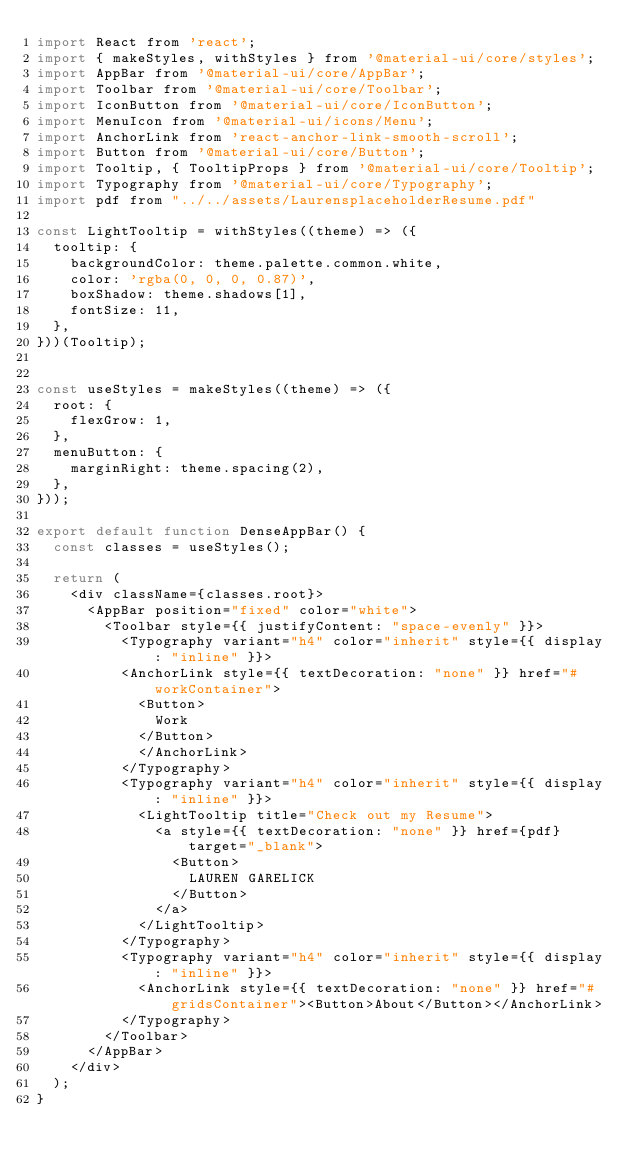<code> <loc_0><loc_0><loc_500><loc_500><_JavaScript_>import React from 'react';
import { makeStyles, withStyles } from '@material-ui/core/styles';
import AppBar from '@material-ui/core/AppBar';
import Toolbar from '@material-ui/core/Toolbar';
import IconButton from '@material-ui/core/IconButton';
import MenuIcon from '@material-ui/icons/Menu';
import AnchorLink from 'react-anchor-link-smooth-scroll';
import Button from '@material-ui/core/Button';
import Tooltip, { TooltipProps } from '@material-ui/core/Tooltip';
import Typography from '@material-ui/core/Typography';
import pdf from "../../assets/LaurensplaceholderResume.pdf"

const LightTooltip = withStyles((theme) => ({
  tooltip: {
    backgroundColor: theme.palette.common.white,
    color: 'rgba(0, 0, 0, 0.87)',
    boxShadow: theme.shadows[1],
    fontSize: 11,
  },
}))(Tooltip);


const useStyles = makeStyles((theme) => ({
  root: {
    flexGrow: 1,
  },
  menuButton: {
    marginRight: theme.spacing(2),
  },
}));

export default function DenseAppBar() {
  const classes = useStyles();

  return (
    <div className={classes.root}>
      <AppBar position="fixed" color="white">
        <Toolbar style={{ justifyContent: "space-evenly" }}>
          <Typography variant="h4" color="inherit" style={{ display: "inline" }}>
          <AnchorLink style={{ textDecoration: "none" }} href="#workContainer">
            <Button>
              Work
            </Button>
            </AnchorLink>
          </Typography>
          <Typography variant="h4" color="inherit" style={{ display: "inline" }}>
            <LightTooltip title="Check out my Resume">
              <a style={{ textDecoration: "none" }} href={pdf} target="_blank">
                <Button>
                  LAUREN GARELICK
                </Button>
              </a>
            </LightTooltip>
          </Typography>
          <Typography variant="h4" color="inherit" style={{ display: "inline" }}>
            <AnchorLink style={{ textDecoration: "none" }} href="#gridsContainer"><Button>About</Button></AnchorLink>
          </Typography>
        </Toolbar>
      </AppBar>
    </div>
  );
}
</code> 